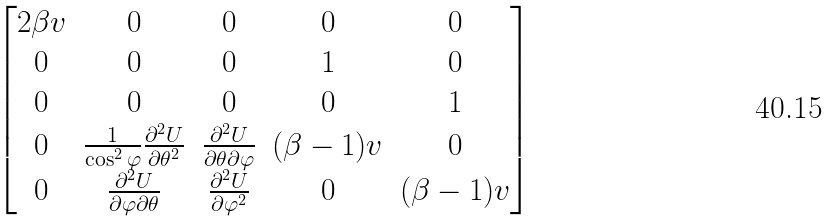<formula> <loc_0><loc_0><loc_500><loc_500>\begin{bmatrix} 2 \beta v & 0 & 0 & 0 & 0 \\ 0 & 0 & 0 & 1 & 0 \\ 0 & 0 & 0 & 0 & 1 \\ 0 & \frac { 1 } { \cos ^ { 2 } \varphi } \frac { \partial ^ { 2 } U } { \partial \theta ^ { 2 } } & \frac { \partial ^ { 2 } U } { \partial \theta \partial \varphi } & ( \beta - 1 ) v & 0 \\ 0 & \frac { \partial ^ { 2 } U } { \partial \varphi \partial \theta } & \frac { \partial ^ { 2 } U } { \partial \varphi ^ { 2 } } & 0 & ( \beta - 1 ) v \\ \end{bmatrix}</formula> 